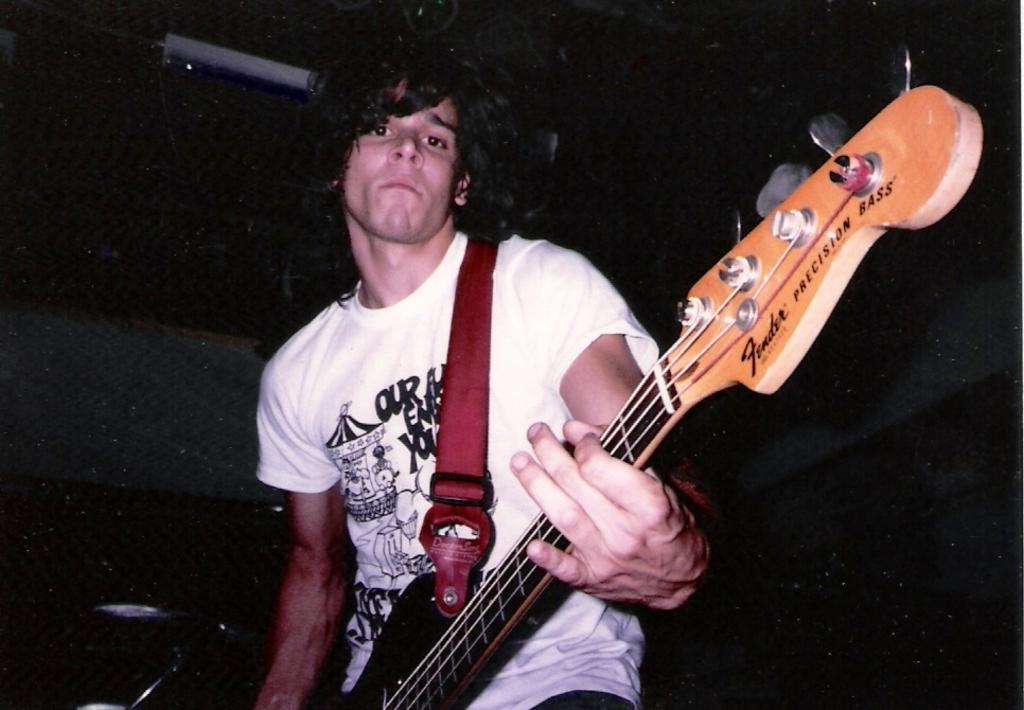What is the man in the image doing? The man is playing the guitar. What object is the man holding in the image? The man is holding a guitar. What type of liquid is the man using to play the guitar in the image? There is no liquid present in the image, and the man is playing the guitar using his hands. 